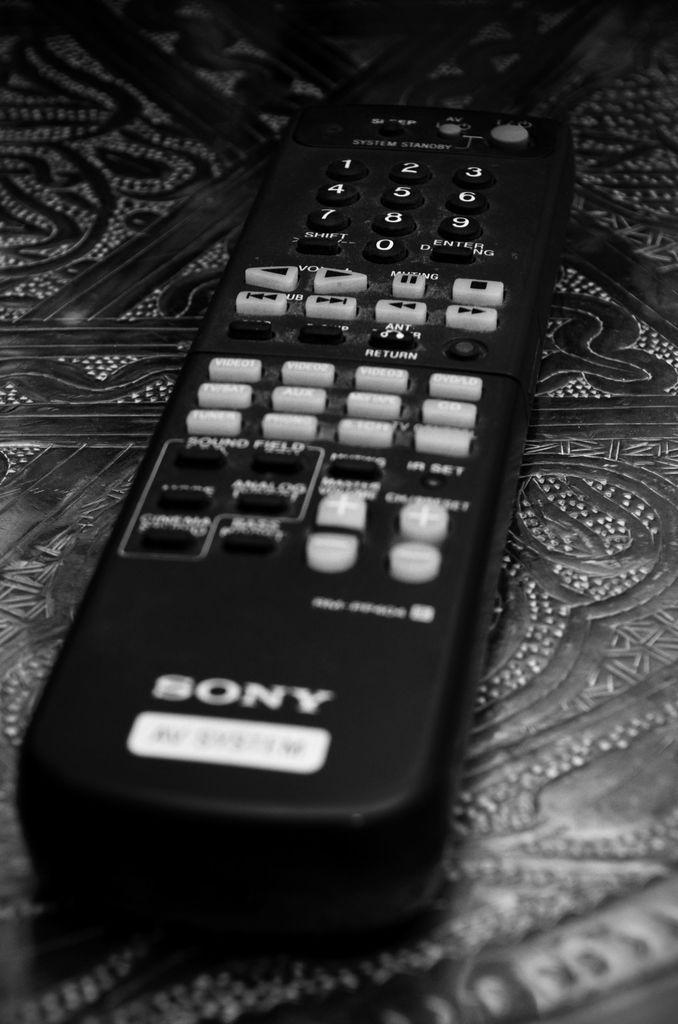What object can be seen in the image? There is a remote in the image. Where is the remote located? The remote is on a surface. What is the color scheme of the image? The image is in black and white. What type of rifle is visible in the image? There is no rifle present in the image; it only features a remote on a surface. What is the sound of thunder like in the image? There is no mention of thunder or any sound in the image, as it is a still image featuring a remote. 